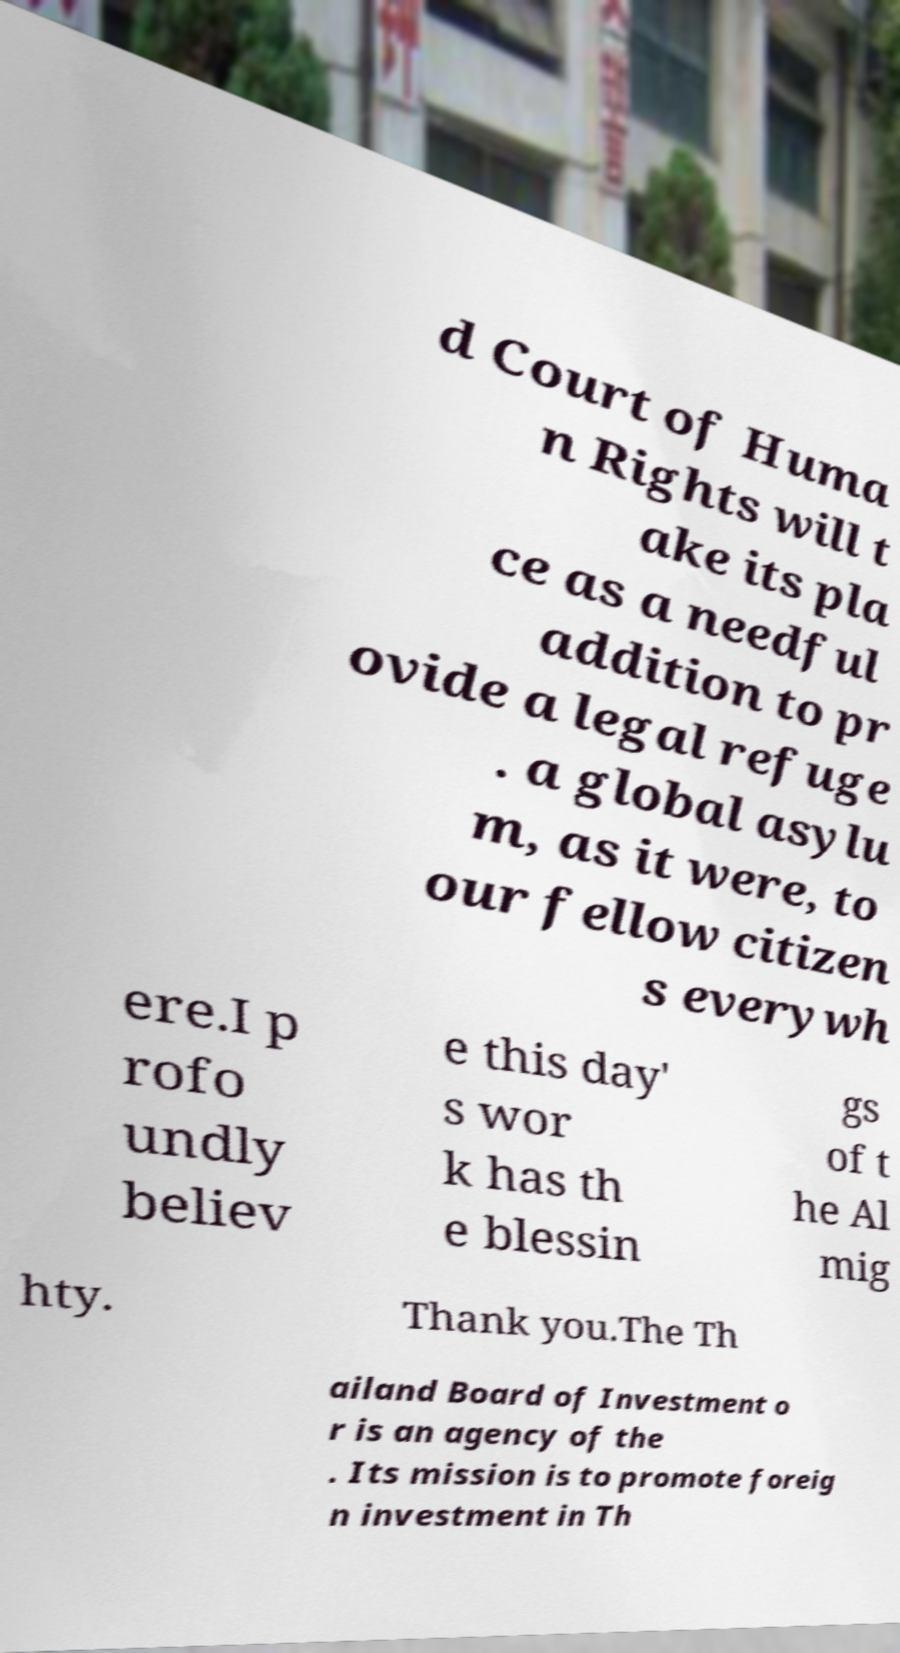For documentation purposes, I need the text within this image transcribed. Could you provide that? d Court of Huma n Rights will t ake its pla ce as a needful addition to pr ovide a legal refuge . a global asylu m, as it were, to our fellow citizen s everywh ere.I p rofo undly believ e this day' s wor k has th e blessin gs of t he Al mig hty. Thank you.The Th ailand Board of Investment o r is an agency of the . Its mission is to promote foreig n investment in Th 